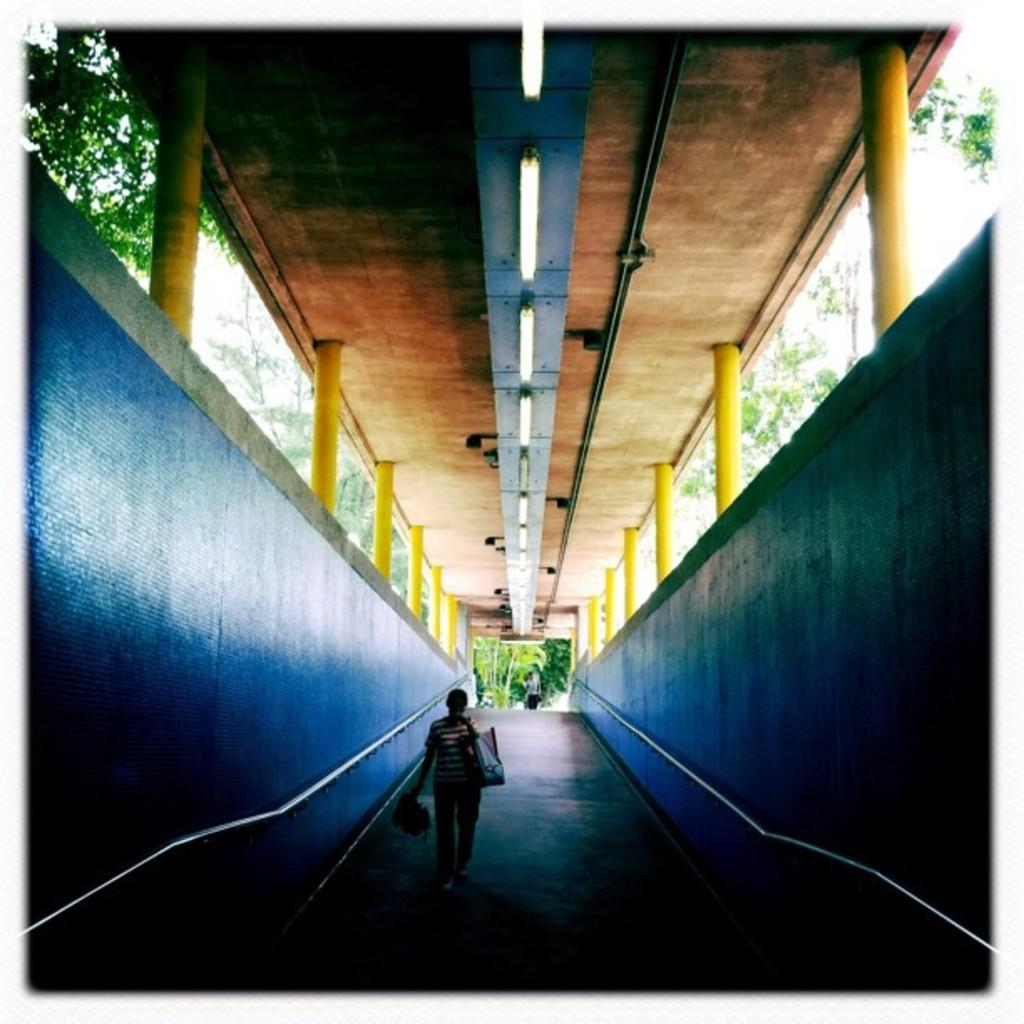What can be seen in the corridor in the image? There are persons on the corridor in the image. What type of structures are visible in the image? Walls, pipes, pillars, and a roof are visible in the image. What type of lighting is present in the image? Lights are present in the image. What type of natural elements can be seen in the image? Trees and the sky are visible in the image. Can you tell me how many snails are crawling on the roof in the image? There are no snails present in the image; the roof is visible but no snails can be seen. What type of harbor can be seen in the image? There is no harbor present in the image; it features a corridor with persons and various structures and elements. 